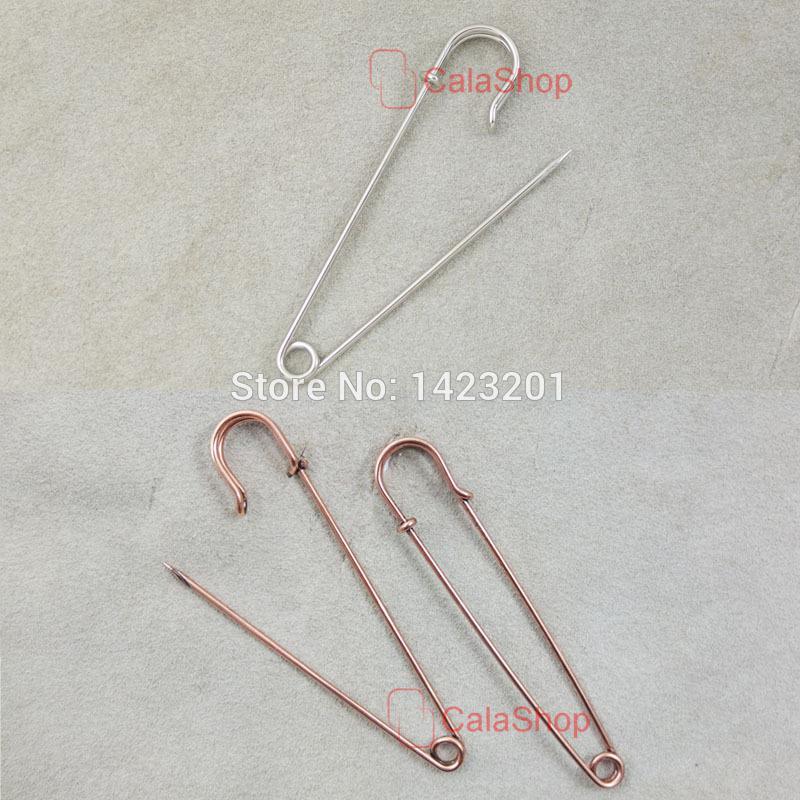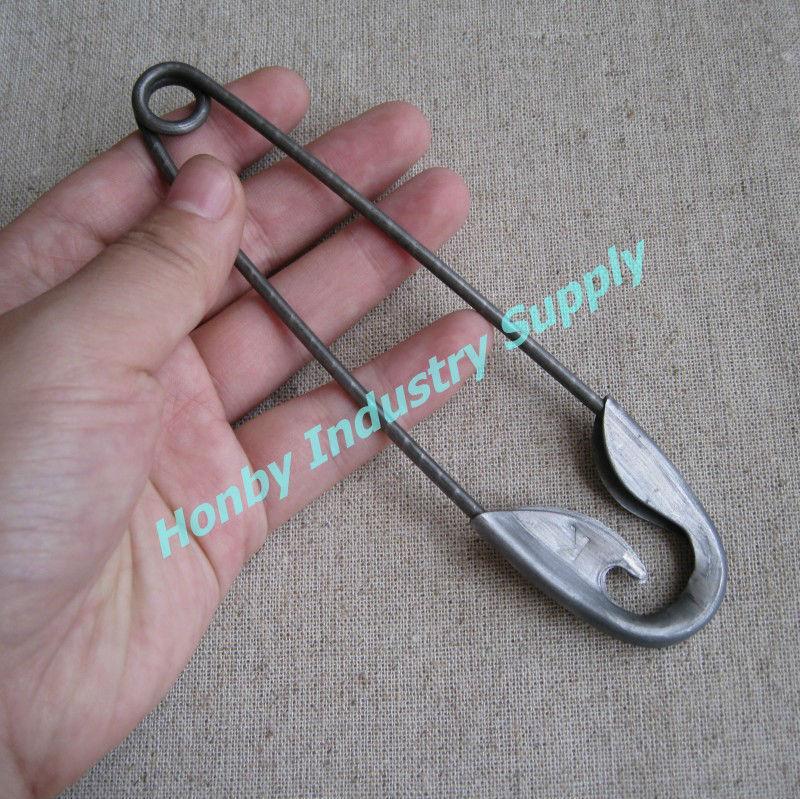The first image is the image on the left, the second image is the image on the right. Assess this claim about the two images: "There is one safety pin that is open.". Correct or not? Answer yes or no. No. 